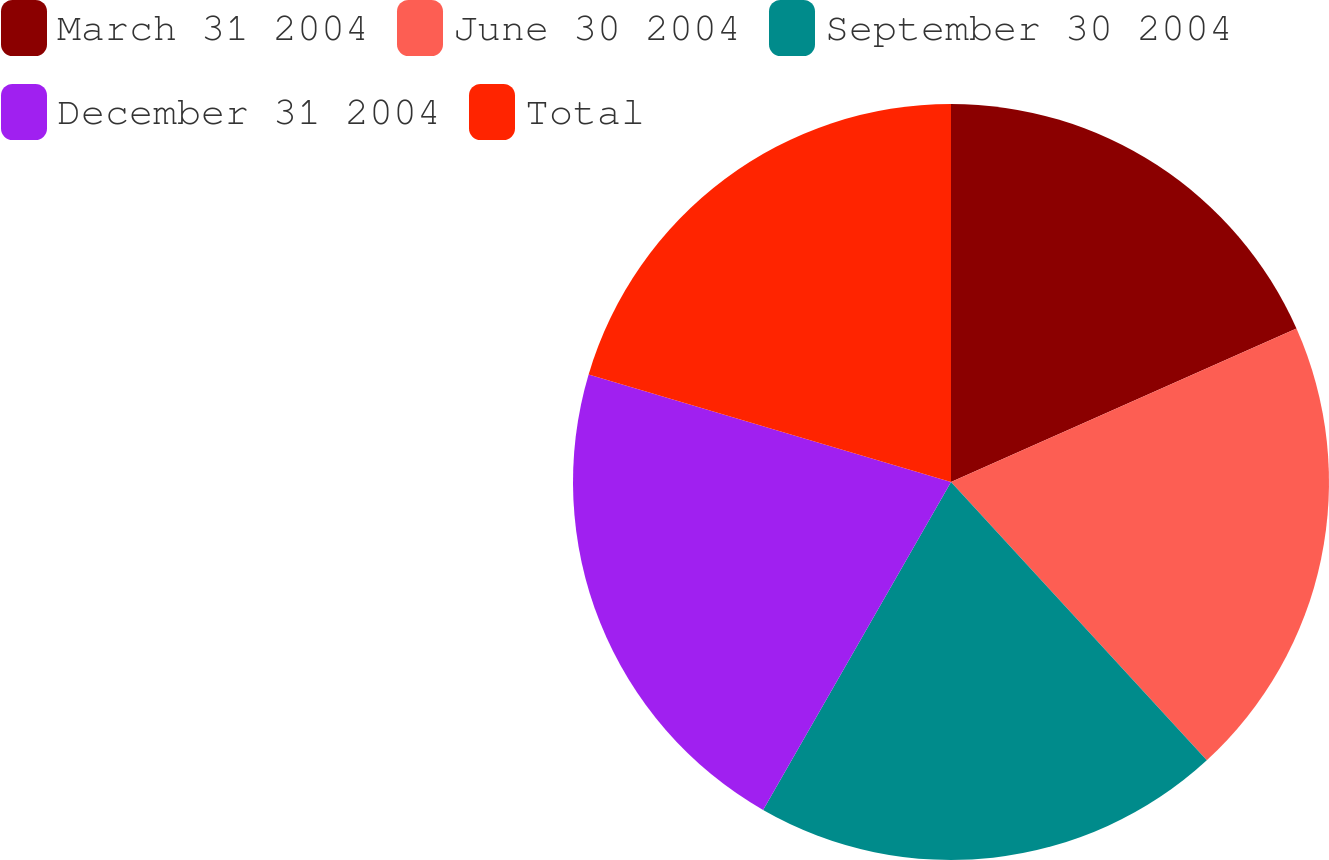Convert chart. <chart><loc_0><loc_0><loc_500><loc_500><pie_chart><fcel>March 31 2004<fcel>June 30 2004<fcel>September 30 2004<fcel>December 31 2004<fcel>Total<nl><fcel>18.35%<fcel>19.82%<fcel>20.11%<fcel>21.31%<fcel>20.41%<nl></chart> 